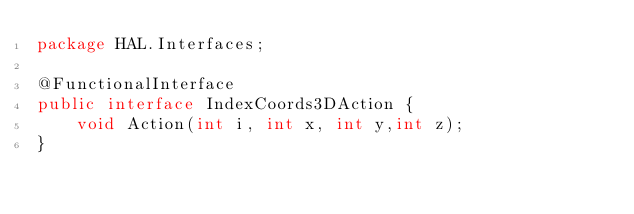<code> <loc_0><loc_0><loc_500><loc_500><_Java_>package HAL.Interfaces;

@FunctionalInterface
public interface IndexCoords3DAction {
    void Action(int i, int x, int y,int z);
}
</code> 